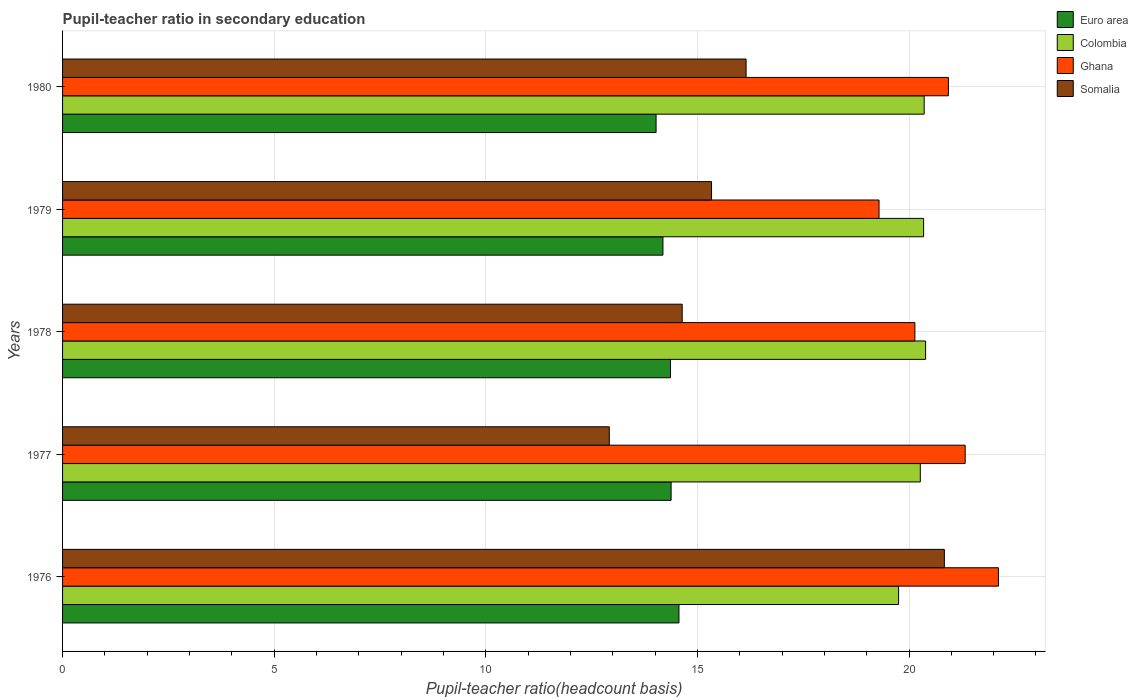How many groups of bars are there?
Ensure brevity in your answer.  5. Are the number of bars on each tick of the Y-axis equal?
Your answer should be compact. Yes. How many bars are there on the 2nd tick from the bottom?
Ensure brevity in your answer.  4. What is the label of the 3rd group of bars from the top?
Ensure brevity in your answer.  1978. What is the pupil-teacher ratio in secondary education in Euro area in 1978?
Offer a terse response. 14.36. Across all years, what is the maximum pupil-teacher ratio in secondary education in Euro area?
Give a very brief answer. 14.56. Across all years, what is the minimum pupil-teacher ratio in secondary education in Ghana?
Give a very brief answer. 19.29. In which year was the pupil-teacher ratio in secondary education in Euro area maximum?
Offer a terse response. 1976. In which year was the pupil-teacher ratio in secondary education in Somalia minimum?
Keep it short and to the point. 1977. What is the total pupil-teacher ratio in secondary education in Euro area in the graph?
Provide a succinct answer. 71.52. What is the difference between the pupil-teacher ratio in secondary education in Euro area in 1979 and that in 1980?
Ensure brevity in your answer.  0.16. What is the difference between the pupil-teacher ratio in secondary education in Somalia in 1980 and the pupil-teacher ratio in secondary education in Ghana in 1977?
Your answer should be compact. -5.18. What is the average pupil-teacher ratio in secondary education in Colombia per year?
Provide a short and direct response. 20.22. In the year 1980, what is the difference between the pupil-teacher ratio in secondary education in Ghana and pupil-teacher ratio in secondary education in Colombia?
Offer a very short reply. 0.57. In how many years, is the pupil-teacher ratio in secondary education in Colombia greater than 9 ?
Provide a succinct answer. 5. What is the ratio of the pupil-teacher ratio in secondary education in Euro area in 1978 to that in 1980?
Offer a very short reply. 1.02. Is the pupil-teacher ratio in secondary education in Euro area in 1976 less than that in 1977?
Give a very brief answer. No. What is the difference between the highest and the second highest pupil-teacher ratio in secondary education in Colombia?
Keep it short and to the point. 0.03. What is the difference between the highest and the lowest pupil-teacher ratio in secondary education in Ghana?
Keep it short and to the point. 2.82. Is it the case that in every year, the sum of the pupil-teacher ratio in secondary education in Ghana and pupil-teacher ratio in secondary education in Colombia is greater than the sum of pupil-teacher ratio in secondary education in Euro area and pupil-teacher ratio in secondary education in Somalia?
Give a very brief answer. No. What does the 4th bar from the top in 1976 represents?
Your answer should be very brief. Euro area. Is it the case that in every year, the sum of the pupil-teacher ratio in secondary education in Euro area and pupil-teacher ratio in secondary education in Colombia is greater than the pupil-teacher ratio in secondary education in Ghana?
Keep it short and to the point. Yes. Where does the legend appear in the graph?
Offer a terse response. Top right. How many legend labels are there?
Keep it short and to the point. 4. What is the title of the graph?
Provide a succinct answer. Pupil-teacher ratio in secondary education. What is the label or title of the X-axis?
Offer a terse response. Pupil-teacher ratio(headcount basis). What is the label or title of the Y-axis?
Give a very brief answer. Years. What is the Pupil-teacher ratio(headcount basis) in Euro area in 1976?
Ensure brevity in your answer.  14.56. What is the Pupil-teacher ratio(headcount basis) in Colombia in 1976?
Offer a terse response. 19.75. What is the Pupil-teacher ratio(headcount basis) of Ghana in 1976?
Offer a terse response. 22.11. What is the Pupil-teacher ratio(headcount basis) in Somalia in 1976?
Offer a terse response. 20.84. What is the Pupil-teacher ratio(headcount basis) of Euro area in 1977?
Offer a very short reply. 14.38. What is the Pupil-teacher ratio(headcount basis) of Colombia in 1977?
Keep it short and to the point. 20.27. What is the Pupil-teacher ratio(headcount basis) in Ghana in 1977?
Provide a succinct answer. 21.33. What is the Pupil-teacher ratio(headcount basis) of Somalia in 1977?
Ensure brevity in your answer.  12.92. What is the Pupil-teacher ratio(headcount basis) in Euro area in 1978?
Your answer should be very brief. 14.36. What is the Pupil-teacher ratio(headcount basis) of Colombia in 1978?
Offer a very short reply. 20.39. What is the Pupil-teacher ratio(headcount basis) in Ghana in 1978?
Your answer should be very brief. 20.14. What is the Pupil-teacher ratio(headcount basis) in Somalia in 1978?
Your answer should be very brief. 14.64. What is the Pupil-teacher ratio(headcount basis) in Euro area in 1979?
Keep it short and to the point. 14.19. What is the Pupil-teacher ratio(headcount basis) in Colombia in 1979?
Provide a succinct answer. 20.34. What is the Pupil-teacher ratio(headcount basis) of Ghana in 1979?
Make the answer very short. 19.29. What is the Pupil-teacher ratio(headcount basis) of Somalia in 1979?
Provide a short and direct response. 15.33. What is the Pupil-teacher ratio(headcount basis) of Euro area in 1980?
Provide a succinct answer. 14.02. What is the Pupil-teacher ratio(headcount basis) in Colombia in 1980?
Your response must be concise. 20.36. What is the Pupil-teacher ratio(headcount basis) of Ghana in 1980?
Provide a succinct answer. 20.93. What is the Pupil-teacher ratio(headcount basis) in Somalia in 1980?
Give a very brief answer. 16.15. Across all years, what is the maximum Pupil-teacher ratio(headcount basis) in Euro area?
Your answer should be compact. 14.56. Across all years, what is the maximum Pupil-teacher ratio(headcount basis) of Colombia?
Your response must be concise. 20.39. Across all years, what is the maximum Pupil-teacher ratio(headcount basis) of Ghana?
Offer a terse response. 22.11. Across all years, what is the maximum Pupil-teacher ratio(headcount basis) of Somalia?
Make the answer very short. 20.84. Across all years, what is the minimum Pupil-teacher ratio(headcount basis) of Euro area?
Provide a short and direct response. 14.02. Across all years, what is the minimum Pupil-teacher ratio(headcount basis) in Colombia?
Make the answer very short. 19.75. Across all years, what is the minimum Pupil-teacher ratio(headcount basis) of Ghana?
Offer a terse response. 19.29. Across all years, what is the minimum Pupil-teacher ratio(headcount basis) in Somalia?
Your response must be concise. 12.92. What is the total Pupil-teacher ratio(headcount basis) in Euro area in the graph?
Your answer should be very brief. 71.52. What is the total Pupil-teacher ratio(headcount basis) in Colombia in the graph?
Your answer should be very brief. 101.12. What is the total Pupil-teacher ratio(headcount basis) of Ghana in the graph?
Provide a succinct answer. 103.8. What is the total Pupil-teacher ratio(headcount basis) in Somalia in the graph?
Make the answer very short. 79.88. What is the difference between the Pupil-teacher ratio(headcount basis) of Euro area in 1976 and that in 1977?
Ensure brevity in your answer.  0.19. What is the difference between the Pupil-teacher ratio(headcount basis) in Colombia in 1976 and that in 1977?
Provide a succinct answer. -0.51. What is the difference between the Pupil-teacher ratio(headcount basis) in Ghana in 1976 and that in 1977?
Your answer should be very brief. 0.79. What is the difference between the Pupil-teacher ratio(headcount basis) of Somalia in 1976 and that in 1977?
Offer a terse response. 7.92. What is the difference between the Pupil-teacher ratio(headcount basis) of Euro area in 1976 and that in 1978?
Provide a succinct answer. 0.2. What is the difference between the Pupil-teacher ratio(headcount basis) in Colombia in 1976 and that in 1978?
Give a very brief answer. -0.64. What is the difference between the Pupil-teacher ratio(headcount basis) of Ghana in 1976 and that in 1978?
Give a very brief answer. 1.97. What is the difference between the Pupil-teacher ratio(headcount basis) of Somalia in 1976 and that in 1978?
Your answer should be very brief. 6.19. What is the difference between the Pupil-teacher ratio(headcount basis) of Euro area in 1976 and that in 1979?
Offer a very short reply. 0.38. What is the difference between the Pupil-teacher ratio(headcount basis) in Colombia in 1976 and that in 1979?
Your response must be concise. -0.59. What is the difference between the Pupil-teacher ratio(headcount basis) of Ghana in 1976 and that in 1979?
Offer a terse response. 2.82. What is the difference between the Pupil-teacher ratio(headcount basis) of Somalia in 1976 and that in 1979?
Keep it short and to the point. 5.5. What is the difference between the Pupil-teacher ratio(headcount basis) of Euro area in 1976 and that in 1980?
Provide a short and direct response. 0.54. What is the difference between the Pupil-teacher ratio(headcount basis) in Colombia in 1976 and that in 1980?
Keep it short and to the point. -0.6. What is the difference between the Pupil-teacher ratio(headcount basis) of Ghana in 1976 and that in 1980?
Your answer should be compact. 1.18. What is the difference between the Pupil-teacher ratio(headcount basis) in Somalia in 1976 and that in 1980?
Your answer should be very brief. 4.68. What is the difference between the Pupil-teacher ratio(headcount basis) of Euro area in 1977 and that in 1978?
Offer a very short reply. 0.01. What is the difference between the Pupil-teacher ratio(headcount basis) of Colombia in 1977 and that in 1978?
Keep it short and to the point. -0.13. What is the difference between the Pupil-teacher ratio(headcount basis) of Ghana in 1977 and that in 1978?
Your response must be concise. 1.19. What is the difference between the Pupil-teacher ratio(headcount basis) in Somalia in 1977 and that in 1978?
Offer a very short reply. -1.72. What is the difference between the Pupil-teacher ratio(headcount basis) of Euro area in 1977 and that in 1979?
Offer a very short reply. 0.19. What is the difference between the Pupil-teacher ratio(headcount basis) in Colombia in 1977 and that in 1979?
Your answer should be very brief. -0.08. What is the difference between the Pupil-teacher ratio(headcount basis) in Ghana in 1977 and that in 1979?
Offer a terse response. 2.04. What is the difference between the Pupil-teacher ratio(headcount basis) in Somalia in 1977 and that in 1979?
Ensure brevity in your answer.  -2.42. What is the difference between the Pupil-teacher ratio(headcount basis) of Euro area in 1977 and that in 1980?
Your answer should be compact. 0.36. What is the difference between the Pupil-teacher ratio(headcount basis) of Colombia in 1977 and that in 1980?
Your answer should be compact. -0.09. What is the difference between the Pupil-teacher ratio(headcount basis) in Ghana in 1977 and that in 1980?
Provide a short and direct response. 0.4. What is the difference between the Pupil-teacher ratio(headcount basis) of Somalia in 1977 and that in 1980?
Your answer should be compact. -3.23. What is the difference between the Pupil-teacher ratio(headcount basis) of Euro area in 1978 and that in 1979?
Provide a succinct answer. 0.18. What is the difference between the Pupil-teacher ratio(headcount basis) of Colombia in 1978 and that in 1979?
Offer a very short reply. 0.05. What is the difference between the Pupil-teacher ratio(headcount basis) of Ghana in 1978 and that in 1979?
Make the answer very short. 0.85. What is the difference between the Pupil-teacher ratio(headcount basis) in Somalia in 1978 and that in 1979?
Offer a terse response. -0.69. What is the difference between the Pupil-teacher ratio(headcount basis) in Euro area in 1978 and that in 1980?
Provide a short and direct response. 0.34. What is the difference between the Pupil-teacher ratio(headcount basis) of Colombia in 1978 and that in 1980?
Your response must be concise. 0.03. What is the difference between the Pupil-teacher ratio(headcount basis) of Ghana in 1978 and that in 1980?
Provide a succinct answer. -0.79. What is the difference between the Pupil-teacher ratio(headcount basis) in Somalia in 1978 and that in 1980?
Keep it short and to the point. -1.51. What is the difference between the Pupil-teacher ratio(headcount basis) of Euro area in 1979 and that in 1980?
Make the answer very short. 0.16. What is the difference between the Pupil-teacher ratio(headcount basis) of Colombia in 1979 and that in 1980?
Offer a very short reply. -0.01. What is the difference between the Pupil-teacher ratio(headcount basis) in Ghana in 1979 and that in 1980?
Your answer should be very brief. -1.64. What is the difference between the Pupil-teacher ratio(headcount basis) of Somalia in 1979 and that in 1980?
Provide a short and direct response. -0.82. What is the difference between the Pupil-teacher ratio(headcount basis) in Euro area in 1976 and the Pupil-teacher ratio(headcount basis) in Colombia in 1977?
Offer a very short reply. -5.7. What is the difference between the Pupil-teacher ratio(headcount basis) in Euro area in 1976 and the Pupil-teacher ratio(headcount basis) in Ghana in 1977?
Make the answer very short. -6.76. What is the difference between the Pupil-teacher ratio(headcount basis) in Euro area in 1976 and the Pupil-teacher ratio(headcount basis) in Somalia in 1977?
Your answer should be very brief. 1.65. What is the difference between the Pupil-teacher ratio(headcount basis) in Colombia in 1976 and the Pupil-teacher ratio(headcount basis) in Ghana in 1977?
Provide a short and direct response. -1.57. What is the difference between the Pupil-teacher ratio(headcount basis) in Colombia in 1976 and the Pupil-teacher ratio(headcount basis) in Somalia in 1977?
Keep it short and to the point. 6.84. What is the difference between the Pupil-teacher ratio(headcount basis) in Ghana in 1976 and the Pupil-teacher ratio(headcount basis) in Somalia in 1977?
Offer a terse response. 9.19. What is the difference between the Pupil-teacher ratio(headcount basis) in Euro area in 1976 and the Pupil-teacher ratio(headcount basis) in Colombia in 1978?
Your response must be concise. -5.83. What is the difference between the Pupil-teacher ratio(headcount basis) in Euro area in 1976 and the Pupil-teacher ratio(headcount basis) in Ghana in 1978?
Keep it short and to the point. -5.57. What is the difference between the Pupil-teacher ratio(headcount basis) in Euro area in 1976 and the Pupil-teacher ratio(headcount basis) in Somalia in 1978?
Provide a succinct answer. -0.08. What is the difference between the Pupil-teacher ratio(headcount basis) in Colombia in 1976 and the Pupil-teacher ratio(headcount basis) in Ghana in 1978?
Your answer should be very brief. -0.39. What is the difference between the Pupil-teacher ratio(headcount basis) in Colombia in 1976 and the Pupil-teacher ratio(headcount basis) in Somalia in 1978?
Provide a succinct answer. 5.11. What is the difference between the Pupil-teacher ratio(headcount basis) of Ghana in 1976 and the Pupil-teacher ratio(headcount basis) of Somalia in 1978?
Offer a very short reply. 7.47. What is the difference between the Pupil-teacher ratio(headcount basis) in Euro area in 1976 and the Pupil-teacher ratio(headcount basis) in Colombia in 1979?
Offer a terse response. -5.78. What is the difference between the Pupil-teacher ratio(headcount basis) of Euro area in 1976 and the Pupil-teacher ratio(headcount basis) of Ghana in 1979?
Ensure brevity in your answer.  -4.73. What is the difference between the Pupil-teacher ratio(headcount basis) of Euro area in 1976 and the Pupil-teacher ratio(headcount basis) of Somalia in 1979?
Provide a short and direct response. -0.77. What is the difference between the Pupil-teacher ratio(headcount basis) of Colombia in 1976 and the Pupil-teacher ratio(headcount basis) of Ghana in 1979?
Provide a succinct answer. 0.46. What is the difference between the Pupil-teacher ratio(headcount basis) of Colombia in 1976 and the Pupil-teacher ratio(headcount basis) of Somalia in 1979?
Ensure brevity in your answer.  4.42. What is the difference between the Pupil-teacher ratio(headcount basis) in Ghana in 1976 and the Pupil-teacher ratio(headcount basis) in Somalia in 1979?
Offer a very short reply. 6.78. What is the difference between the Pupil-teacher ratio(headcount basis) of Euro area in 1976 and the Pupil-teacher ratio(headcount basis) of Colombia in 1980?
Keep it short and to the point. -5.79. What is the difference between the Pupil-teacher ratio(headcount basis) in Euro area in 1976 and the Pupil-teacher ratio(headcount basis) in Ghana in 1980?
Offer a very short reply. -6.37. What is the difference between the Pupil-teacher ratio(headcount basis) of Euro area in 1976 and the Pupil-teacher ratio(headcount basis) of Somalia in 1980?
Offer a terse response. -1.59. What is the difference between the Pupil-teacher ratio(headcount basis) of Colombia in 1976 and the Pupil-teacher ratio(headcount basis) of Ghana in 1980?
Keep it short and to the point. -1.18. What is the difference between the Pupil-teacher ratio(headcount basis) of Colombia in 1976 and the Pupil-teacher ratio(headcount basis) of Somalia in 1980?
Offer a very short reply. 3.6. What is the difference between the Pupil-teacher ratio(headcount basis) of Ghana in 1976 and the Pupil-teacher ratio(headcount basis) of Somalia in 1980?
Keep it short and to the point. 5.96. What is the difference between the Pupil-teacher ratio(headcount basis) of Euro area in 1977 and the Pupil-teacher ratio(headcount basis) of Colombia in 1978?
Provide a short and direct response. -6.01. What is the difference between the Pupil-teacher ratio(headcount basis) in Euro area in 1977 and the Pupil-teacher ratio(headcount basis) in Ghana in 1978?
Your response must be concise. -5.76. What is the difference between the Pupil-teacher ratio(headcount basis) in Euro area in 1977 and the Pupil-teacher ratio(headcount basis) in Somalia in 1978?
Your answer should be compact. -0.26. What is the difference between the Pupil-teacher ratio(headcount basis) in Colombia in 1977 and the Pupil-teacher ratio(headcount basis) in Ghana in 1978?
Offer a very short reply. 0.13. What is the difference between the Pupil-teacher ratio(headcount basis) of Colombia in 1977 and the Pupil-teacher ratio(headcount basis) of Somalia in 1978?
Make the answer very short. 5.63. What is the difference between the Pupil-teacher ratio(headcount basis) in Ghana in 1977 and the Pupil-teacher ratio(headcount basis) in Somalia in 1978?
Your response must be concise. 6.69. What is the difference between the Pupil-teacher ratio(headcount basis) in Euro area in 1977 and the Pupil-teacher ratio(headcount basis) in Colombia in 1979?
Provide a short and direct response. -5.97. What is the difference between the Pupil-teacher ratio(headcount basis) of Euro area in 1977 and the Pupil-teacher ratio(headcount basis) of Ghana in 1979?
Make the answer very short. -4.91. What is the difference between the Pupil-teacher ratio(headcount basis) in Euro area in 1977 and the Pupil-teacher ratio(headcount basis) in Somalia in 1979?
Provide a succinct answer. -0.95. What is the difference between the Pupil-teacher ratio(headcount basis) in Colombia in 1977 and the Pupil-teacher ratio(headcount basis) in Ghana in 1979?
Offer a very short reply. 0.97. What is the difference between the Pupil-teacher ratio(headcount basis) in Colombia in 1977 and the Pupil-teacher ratio(headcount basis) in Somalia in 1979?
Provide a succinct answer. 4.93. What is the difference between the Pupil-teacher ratio(headcount basis) in Ghana in 1977 and the Pupil-teacher ratio(headcount basis) in Somalia in 1979?
Offer a terse response. 5.99. What is the difference between the Pupil-teacher ratio(headcount basis) of Euro area in 1977 and the Pupil-teacher ratio(headcount basis) of Colombia in 1980?
Keep it short and to the point. -5.98. What is the difference between the Pupil-teacher ratio(headcount basis) of Euro area in 1977 and the Pupil-teacher ratio(headcount basis) of Ghana in 1980?
Provide a succinct answer. -6.55. What is the difference between the Pupil-teacher ratio(headcount basis) in Euro area in 1977 and the Pupil-teacher ratio(headcount basis) in Somalia in 1980?
Make the answer very short. -1.77. What is the difference between the Pupil-teacher ratio(headcount basis) in Colombia in 1977 and the Pupil-teacher ratio(headcount basis) in Ghana in 1980?
Give a very brief answer. -0.66. What is the difference between the Pupil-teacher ratio(headcount basis) in Colombia in 1977 and the Pupil-teacher ratio(headcount basis) in Somalia in 1980?
Provide a short and direct response. 4.12. What is the difference between the Pupil-teacher ratio(headcount basis) of Ghana in 1977 and the Pupil-teacher ratio(headcount basis) of Somalia in 1980?
Offer a very short reply. 5.18. What is the difference between the Pupil-teacher ratio(headcount basis) of Euro area in 1978 and the Pupil-teacher ratio(headcount basis) of Colombia in 1979?
Your answer should be compact. -5.98. What is the difference between the Pupil-teacher ratio(headcount basis) in Euro area in 1978 and the Pupil-teacher ratio(headcount basis) in Ghana in 1979?
Ensure brevity in your answer.  -4.93. What is the difference between the Pupil-teacher ratio(headcount basis) of Euro area in 1978 and the Pupil-teacher ratio(headcount basis) of Somalia in 1979?
Offer a very short reply. -0.97. What is the difference between the Pupil-teacher ratio(headcount basis) in Colombia in 1978 and the Pupil-teacher ratio(headcount basis) in Ghana in 1979?
Keep it short and to the point. 1.1. What is the difference between the Pupil-teacher ratio(headcount basis) of Colombia in 1978 and the Pupil-teacher ratio(headcount basis) of Somalia in 1979?
Provide a succinct answer. 5.06. What is the difference between the Pupil-teacher ratio(headcount basis) in Ghana in 1978 and the Pupil-teacher ratio(headcount basis) in Somalia in 1979?
Offer a very short reply. 4.8. What is the difference between the Pupil-teacher ratio(headcount basis) in Euro area in 1978 and the Pupil-teacher ratio(headcount basis) in Colombia in 1980?
Give a very brief answer. -5.99. What is the difference between the Pupil-teacher ratio(headcount basis) in Euro area in 1978 and the Pupil-teacher ratio(headcount basis) in Ghana in 1980?
Make the answer very short. -6.57. What is the difference between the Pupil-teacher ratio(headcount basis) of Euro area in 1978 and the Pupil-teacher ratio(headcount basis) of Somalia in 1980?
Ensure brevity in your answer.  -1.79. What is the difference between the Pupil-teacher ratio(headcount basis) of Colombia in 1978 and the Pupil-teacher ratio(headcount basis) of Ghana in 1980?
Your answer should be very brief. -0.54. What is the difference between the Pupil-teacher ratio(headcount basis) of Colombia in 1978 and the Pupil-teacher ratio(headcount basis) of Somalia in 1980?
Your response must be concise. 4.24. What is the difference between the Pupil-teacher ratio(headcount basis) in Ghana in 1978 and the Pupil-teacher ratio(headcount basis) in Somalia in 1980?
Your answer should be very brief. 3.99. What is the difference between the Pupil-teacher ratio(headcount basis) in Euro area in 1979 and the Pupil-teacher ratio(headcount basis) in Colombia in 1980?
Make the answer very short. -6.17. What is the difference between the Pupil-teacher ratio(headcount basis) of Euro area in 1979 and the Pupil-teacher ratio(headcount basis) of Ghana in 1980?
Your answer should be very brief. -6.75. What is the difference between the Pupil-teacher ratio(headcount basis) of Euro area in 1979 and the Pupil-teacher ratio(headcount basis) of Somalia in 1980?
Keep it short and to the point. -1.96. What is the difference between the Pupil-teacher ratio(headcount basis) in Colombia in 1979 and the Pupil-teacher ratio(headcount basis) in Ghana in 1980?
Provide a succinct answer. -0.59. What is the difference between the Pupil-teacher ratio(headcount basis) of Colombia in 1979 and the Pupil-teacher ratio(headcount basis) of Somalia in 1980?
Provide a short and direct response. 4.19. What is the difference between the Pupil-teacher ratio(headcount basis) of Ghana in 1979 and the Pupil-teacher ratio(headcount basis) of Somalia in 1980?
Keep it short and to the point. 3.14. What is the average Pupil-teacher ratio(headcount basis) in Euro area per year?
Provide a succinct answer. 14.3. What is the average Pupil-teacher ratio(headcount basis) of Colombia per year?
Provide a short and direct response. 20.22. What is the average Pupil-teacher ratio(headcount basis) in Ghana per year?
Keep it short and to the point. 20.76. What is the average Pupil-teacher ratio(headcount basis) in Somalia per year?
Your answer should be very brief. 15.98. In the year 1976, what is the difference between the Pupil-teacher ratio(headcount basis) in Euro area and Pupil-teacher ratio(headcount basis) in Colombia?
Provide a succinct answer. -5.19. In the year 1976, what is the difference between the Pupil-teacher ratio(headcount basis) of Euro area and Pupil-teacher ratio(headcount basis) of Ghana?
Your answer should be compact. -7.55. In the year 1976, what is the difference between the Pupil-teacher ratio(headcount basis) in Euro area and Pupil-teacher ratio(headcount basis) in Somalia?
Make the answer very short. -6.27. In the year 1976, what is the difference between the Pupil-teacher ratio(headcount basis) in Colombia and Pupil-teacher ratio(headcount basis) in Ghana?
Offer a terse response. -2.36. In the year 1976, what is the difference between the Pupil-teacher ratio(headcount basis) in Colombia and Pupil-teacher ratio(headcount basis) in Somalia?
Your answer should be very brief. -1.08. In the year 1976, what is the difference between the Pupil-teacher ratio(headcount basis) of Ghana and Pupil-teacher ratio(headcount basis) of Somalia?
Provide a short and direct response. 1.28. In the year 1977, what is the difference between the Pupil-teacher ratio(headcount basis) in Euro area and Pupil-teacher ratio(headcount basis) in Colombia?
Provide a succinct answer. -5.89. In the year 1977, what is the difference between the Pupil-teacher ratio(headcount basis) of Euro area and Pupil-teacher ratio(headcount basis) of Ghana?
Your answer should be compact. -6.95. In the year 1977, what is the difference between the Pupil-teacher ratio(headcount basis) in Euro area and Pupil-teacher ratio(headcount basis) in Somalia?
Ensure brevity in your answer.  1.46. In the year 1977, what is the difference between the Pupil-teacher ratio(headcount basis) of Colombia and Pupil-teacher ratio(headcount basis) of Ghana?
Your answer should be very brief. -1.06. In the year 1977, what is the difference between the Pupil-teacher ratio(headcount basis) of Colombia and Pupil-teacher ratio(headcount basis) of Somalia?
Your response must be concise. 7.35. In the year 1977, what is the difference between the Pupil-teacher ratio(headcount basis) in Ghana and Pupil-teacher ratio(headcount basis) in Somalia?
Make the answer very short. 8.41. In the year 1978, what is the difference between the Pupil-teacher ratio(headcount basis) in Euro area and Pupil-teacher ratio(headcount basis) in Colombia?
Your response must be concise. -6.03. In the year 1978, what is the difference between the Pupil-teacher ratio(headcount basis) of Euro area and Pupil-teacher ratio(headcount basis) of Ghana?
Offer a very short reply. -5.77. In the year 1978, what is the difference between the Pupil-teacher ratio(headcount basis) in Euro area and Pupil-teacher ratio(headcount basis) in Somalia?
Keep it short and to the point. -0.28. In the year 1978, what is the difference between the Pupil-teacher ratio(headcount basis) in Colombia and Pupil-teacher ratio(headcount basis) in Ghana?
Ensure brevity in your answer.  0.25. In the year 1978, what is the difference between the Pupil-teacher ratio(headcount basis) of Colombia and Pupil-teacher ratio(headcount basis) of Somalia?
Give a very brief answer. 5.75. In the year 1978, what is the difference between the Pupil-teacher ratio(headcount basis) in Ghana and Pupil-teacher ratio(headcount basis) in Somalia?
Ensure brevity in your answer.  5.5. In the year 1979, what is the difference between the Pupil-teacher ratio(headcount basis) of Euro area and Pupil-teacher ratio(headcount basis) of Colombia?
Provide a short and direct response. -6.16. In the year 1979, what is the difference between the Pupil-teacher ratio(headcount basis) in Euro area and Pupil-teacher ratio(headcount basis) in Ghana?
Your answer should be compact. -5.11. In the year 1979, what is the difference between the Pupil-teacher ratio(headcount basis) of Euro area and Pupil-teacher ratio(headcount basis) of Somalia?
Offer a terse response. -1.15. In the year 1979, what is the difference between the Pupil-teacher ratio(headcount basis) in Colombia and Pupil-teacher ratio(headcount basis) in Ghana?
Provide a short and direct response. 1.05. In the year 1979, what is the difference between the Pupil-teacher ratio(headcount basis) of Colombia and Pupil-teacher ratio(headcount basis) of Somalia?
Make the answer very short. 5.01. In the year 1979, what is the difference between the Pupil-teacher ratio(headcount basis) in Ghana and Pupil-teacher ratio(headcount basis) in Somalia?
Your answer should be very brief. 3.96. In the year 1980, what is the difference between the Pupil-teacher ratio(headcount basis) of Euro area and Pupil-teacher ratio(headcount basis) of Colombia?
Offer a very short reply. -6.33. In the year 1980, what is the difference between the Pupil-teacher ratio(headcount basis) in Euro area and Pupil-teacher ratio(headcount basis) in Ghana?
Your answer should be very brief. -6.91. In the year 1980, what is the difference between the Pupil-teacher ratio(headcount basis) in Euro area and Pupil-teacher ratio(headcount basis) in Somalia?
Your answer should be compact. -2.13. In the year 1980, what is the difference between the Pupil-teacher ratio(headcount basis) in Colombia and Pupil-teacher ratio(headcount basis) in Ghana?
Provide a succinct answer. -0.57. In the year 1980, what is the difference between the Pupil-teacher ratio(headcount basis) of Colombia and Pupil-teacher ratio(headcount basis) of Somalia?
Offer a very short reply. 4.21. In the year 1980, what is the difference between the Pupil-teacher ratio(headcount basis) in Ghana and Pupil-teacher ratio(headcount basis) in Somalia?
Your answer should be compact. 4.78. What is the ratio of the Pupil-teacher ratio(headcount basis) of Euro area in 1976 to that in 1977?
Your answer should be compact. 1.01. What is the ratio of the Pupil-teacher ratio(headcount basis) in Colombia in 1976 to that in 1977?
Keep it short and to the point. 0.97. What is the ratio of the Pupil-teacher ratio(headcount basis) of Ghana in 1976 to that in 1977?
Your answer should be compact. 1.04. What is the ratio of the Pupil-teacher ratio(headcount basis) of Somalia in 1976 to that in 1977?
Provide a succinct answer. 1.61. What is the ratio of the Pupil-teacher ratio(headcount basis) of Euro area in 1976 to that in 1978?
Make the answer very short. 1.01. What is the ratio of the Pupil-teacher ratio(headcount basis) in Colombia in 1976 to that in 1978?
Provide a short and direct response. 0.97. What is the ratio of the Pupil-teacher ratio(headcount basis) of Ghana in 1976 to that in 1978?
Offer a very short reply. 1.1. What is the ratio of the Pupil-teacher ratio(headcount basis) in Somalia in 1976 to that in 1978?
Give a very brief answer. 1.42. What is the ratio of the Pupil-teacher ratio(headcount basis) of Euro area in 1976 to that in 1979?
Make the answer very short. 1.03. What is the ratio of the Pupil-teacher ratio(headcount basis) in Colombia in 1976 to that in 1979?
Give a very brief answer. 0.97. What is the ratio of the Pupil-teacher ratio(headcount basis) in Ghana in 1976 to that in 1979?
Provide a short and direct response. 1.15. What is the ratio of the Pupil-teacher ratio(headcount basis) of Somalia in 1976 to that in 1979?
Your answer should be compact. 1.36. What is the ratio of the Pupil-teacher ratio(headcount basis) of Colombia in 1976 to that in 1980?
Keep it short and to the point. 0.97. What is the ratio of the Pupil-teacher ratio(headcount basis) of Ghana in 1976 to that in 1980?
Offer a terse response. 1.06. What is the ratio of the Pupil-teacher ratio(headcount basis) in Somalia in 1976 to that in 1980?
Give a very brief answer. 1.29. What is the ratio of the Pupil-teacher ratio(headcount basis) of Ghana in 1977 to that in 1978?
Your response must be concise. 1.06. What is the ratio of the Pupil-teacher ratio(headcount basis) of Somalia in 1977 to that in 1978?
Provide a succinct answer. 0.88. What is the ratio of the Pupil-teacher ratio(headcount basis) in Euro area in 1977 to that in 1979?
Ensure brevity in your answer.  1.01. What is the ratio of the Pupil-teacher ratio(headcount basis) in Colombia in 1977 to that in 1979?
Keep it short and to the point. 1. What is the ratio of the Pupil-teacher ratio(headcount basis) of Ghana in 1977 to that in 1979?
Make the answer very short. 1.11. What is the ratio of the Pupil-teacher ratio(headcount basis) in Somalia in 1977 to that in 1979?
Your answer should be compact. 0.84. What is the ratio of the Pupil-teacher ratio(headcount basis) of Euro area in 1977 to that in 1980?
Offer a very short reply. 1.03. What is the ratio of the Pupil-teacher ratio(headcount basis) of Colombia in 1977 to that in 1980?
Make the answer very short. 1. What is the ratio of the Pupil-teacher ratio(headcount basis) in Ghana in 1977 to that in 1980?
Make the answer very short. 1.02. What is the ratio of the Pupil-teacher ratio(headcount basis) of Somalia in 1977 to that in 1980?
Make the answer very short. 0.8. What is the ratio of the Pupil-teacher ratio(headcount basis) of Euro area in 1978 to that in 1979?
Your answer should be very brief. 1.01. What is the ratio of the Pupil-teacher ratio(headcount basis) of Ghana in 1978 to that in 1979?
Your answer should be very brief. 1.04. What is the ratio of the Pupil-teacher ratio(headcount basis) of Somalia in 1978 to that in 1979?
Ensure brevity in your answer.  0.95. What is the ratio of the Pupil-teacher ratio(headcount basis) of Euro area in 1978 to that in 1980?
Provide a succinct answer. 1.02. What is the ratio of the Pupil-teacher ratio(headcount basis) of Ghana in 1978 to that in 1980?
Give a very brief answer. 0.96. What is the ratio of the Pupil-teacher ratio(headcount basis) of Somalia in 1978 to that in 1980?
Provide a succinct answer. 0.91. What is the ratio of the Pupil-teacher ratio(headcount basis) of Euro area in 1979 to that in 1980?
Offer a terse response. 1.01. What is the ratio of the Pupil-teacher ratio(headcount basis) of Ghana in 1979 to that in 1980?
Provide a succinct answer. 0.92. What is the ratio of the Pupil-teacher ratio(headcount basis) of Somalia in 1979 to that in 1980?
Your answer should be compact. 0.95. What is the difference between the highest and the second highest Pupil-teacher ratio(headcount basis) of Euro area?
Offer a very short reply. 0.19. What is the difference between the highest and the second highest Pupil-teacher ratio(headcount basis) in Colombia?
Your answer should be compact. 0.03. What is the difference between the highest and the second highest Pupil-teacher ratio(headcount basis) in Ghana?
Keep it short and to the point. 0.79. What is the difference between the highest and the second highest Pupil-teacher ratio(headcount basis) of Somalia?
Offer a terse response. 4.68. What is the difference between the highest and the lowest Pupil-teacher ratio(headcount basis) of Euro area?
Your answer should be compact. 0.54. What is the difference between the highest and the lowest Pupil-teacher ratio(headcount basis) in Colombia?
Make the answer very short. 0.64. What is the difference between the highest and the lowest Pupil-teacher ratio(headcount basis) of Ghana?
Provide a succinct answer. 2.82. What is the difference between the highest and the lowest Pupil-teacher ratio(headcount basis) in Somalia?
Offer a very short reply. 7.92. 